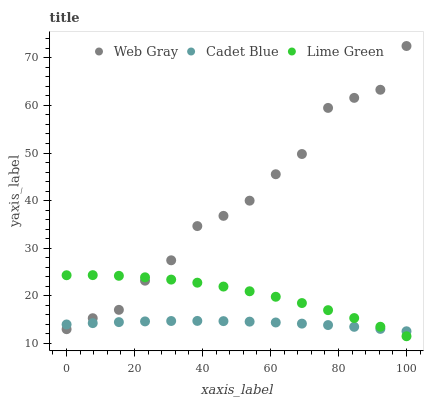Does Cadet Blue have the minimum area under the curve?
Answer yes or no. Yes. Does Web Gray have the maximum area under the curve?
Answer yes or no. Yes. Does Lime Green have the minimum area under the curve?
Answer yes or no. No. Does Lime Green have the maximum area under the curve?
Answer yes or no. No. Is Cadet Blue the smoothest?
Answer yes or no. Yes. Is Web Gray the roughest?
Answer yes or no. Yes. Is Lime Green the smoothest?
Answer yes or no. No. Is Lime Green the roughest?
Answer yes or no. No. Does Lime Green have the lowest value?
Answer yes or no. Yes. Does Web Gray have the lowest value?
Answer yes or no. No. Does Web Gray have the highest value?
Answer yes or no. Yes. Does Lime Green have the highest value?
Answer yes or no. No. Does Lime Green intersect Web Gray?
Answer yes or no. Yes. Is Lime Green less than Web Gray?
Answer yes or no. No. Is Lime Green greater than Web Gray?
Answer yes or no. No. 